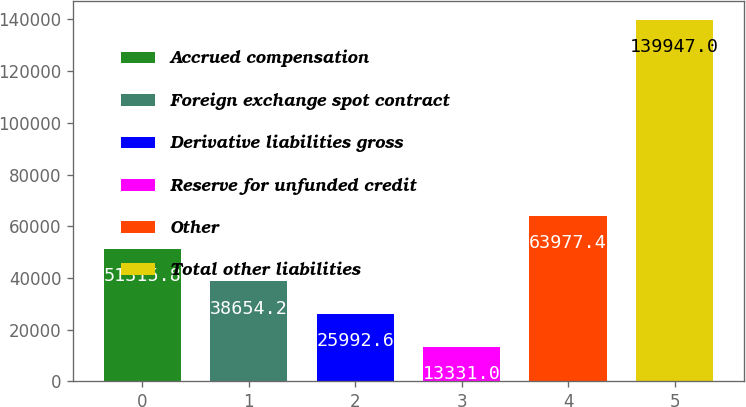Convert chart. <chart><loc_0><loc_0><loc_500><loc_500><bar_chart><fcel>Accrued compensation<fcel>Foreign exchange spot contract<fcel>Derivative liabilities gross<fcel>Reserve for unfunded credit<fcel>Other<fcel>Total other liabilities<nl><fcel>51315.8<fcel>38654.2<fcel>25992.6<fcel>13331<fcel>63977.4<fcel>139947<nl></chart> 